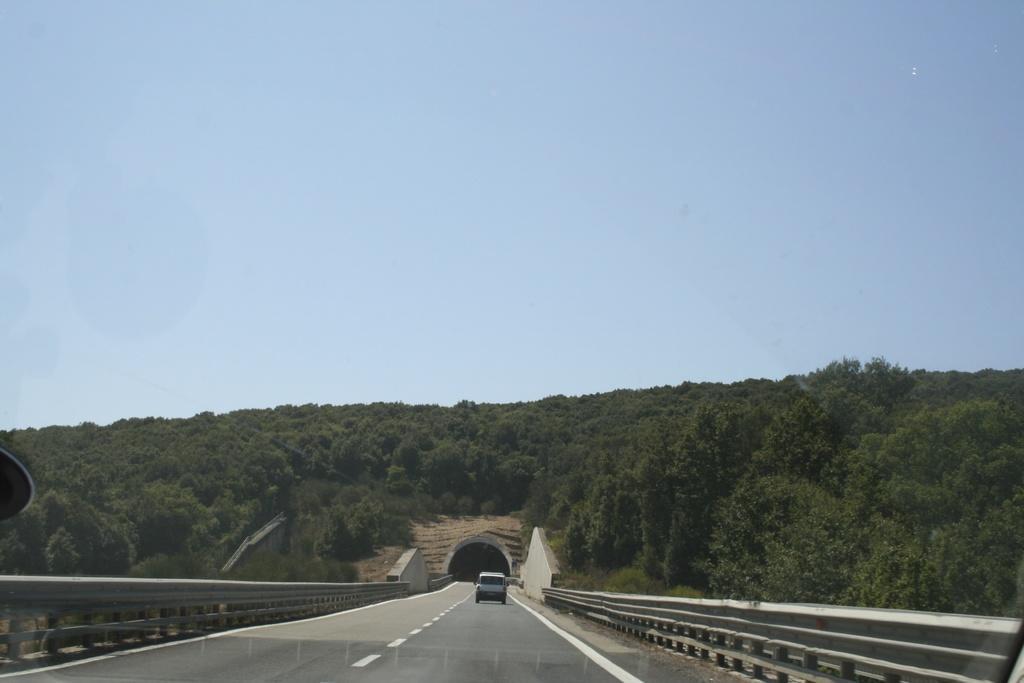Describe this image in one or two sentences. In this image in the front there is a road and in the center there is a car moving on the road. In the background there are trees and there is fence on both sides of the road. 